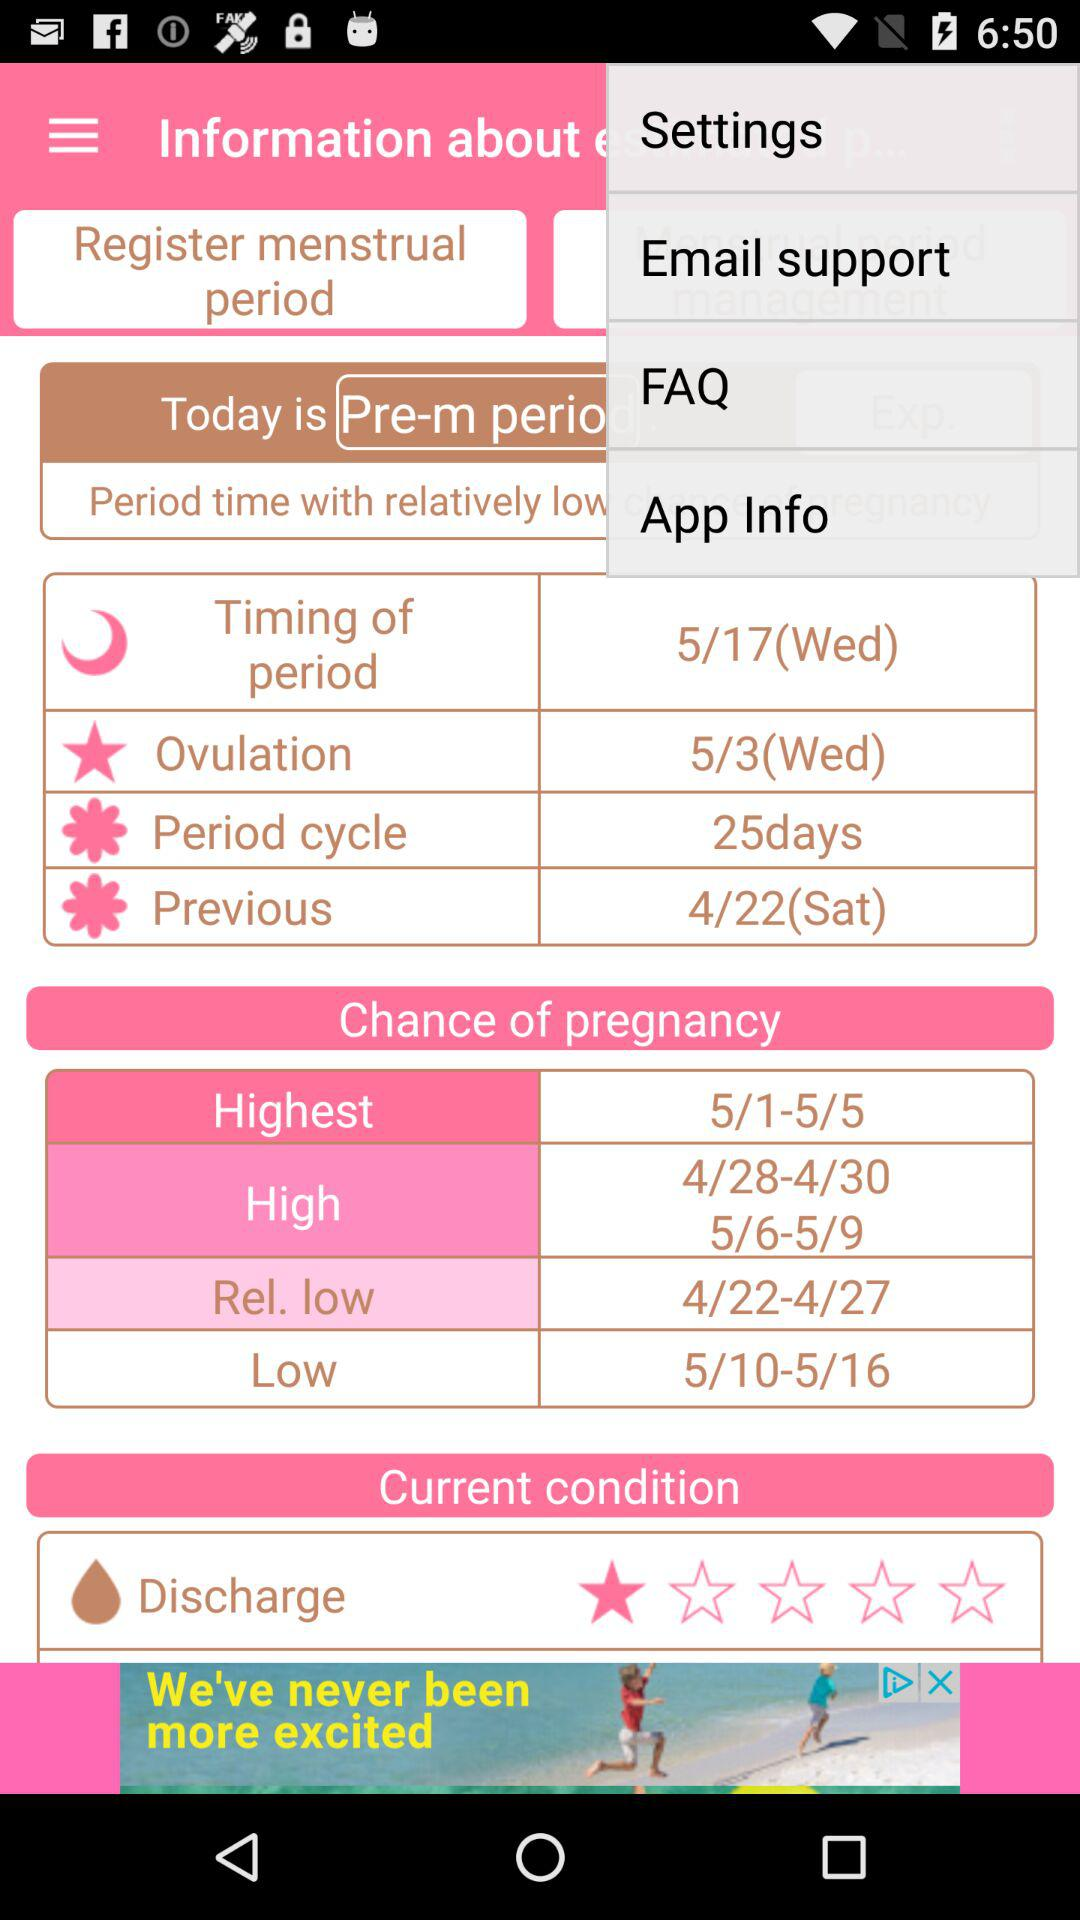How many days are in my period cycle?
Answer the question using a single word or phrase. 25 days 